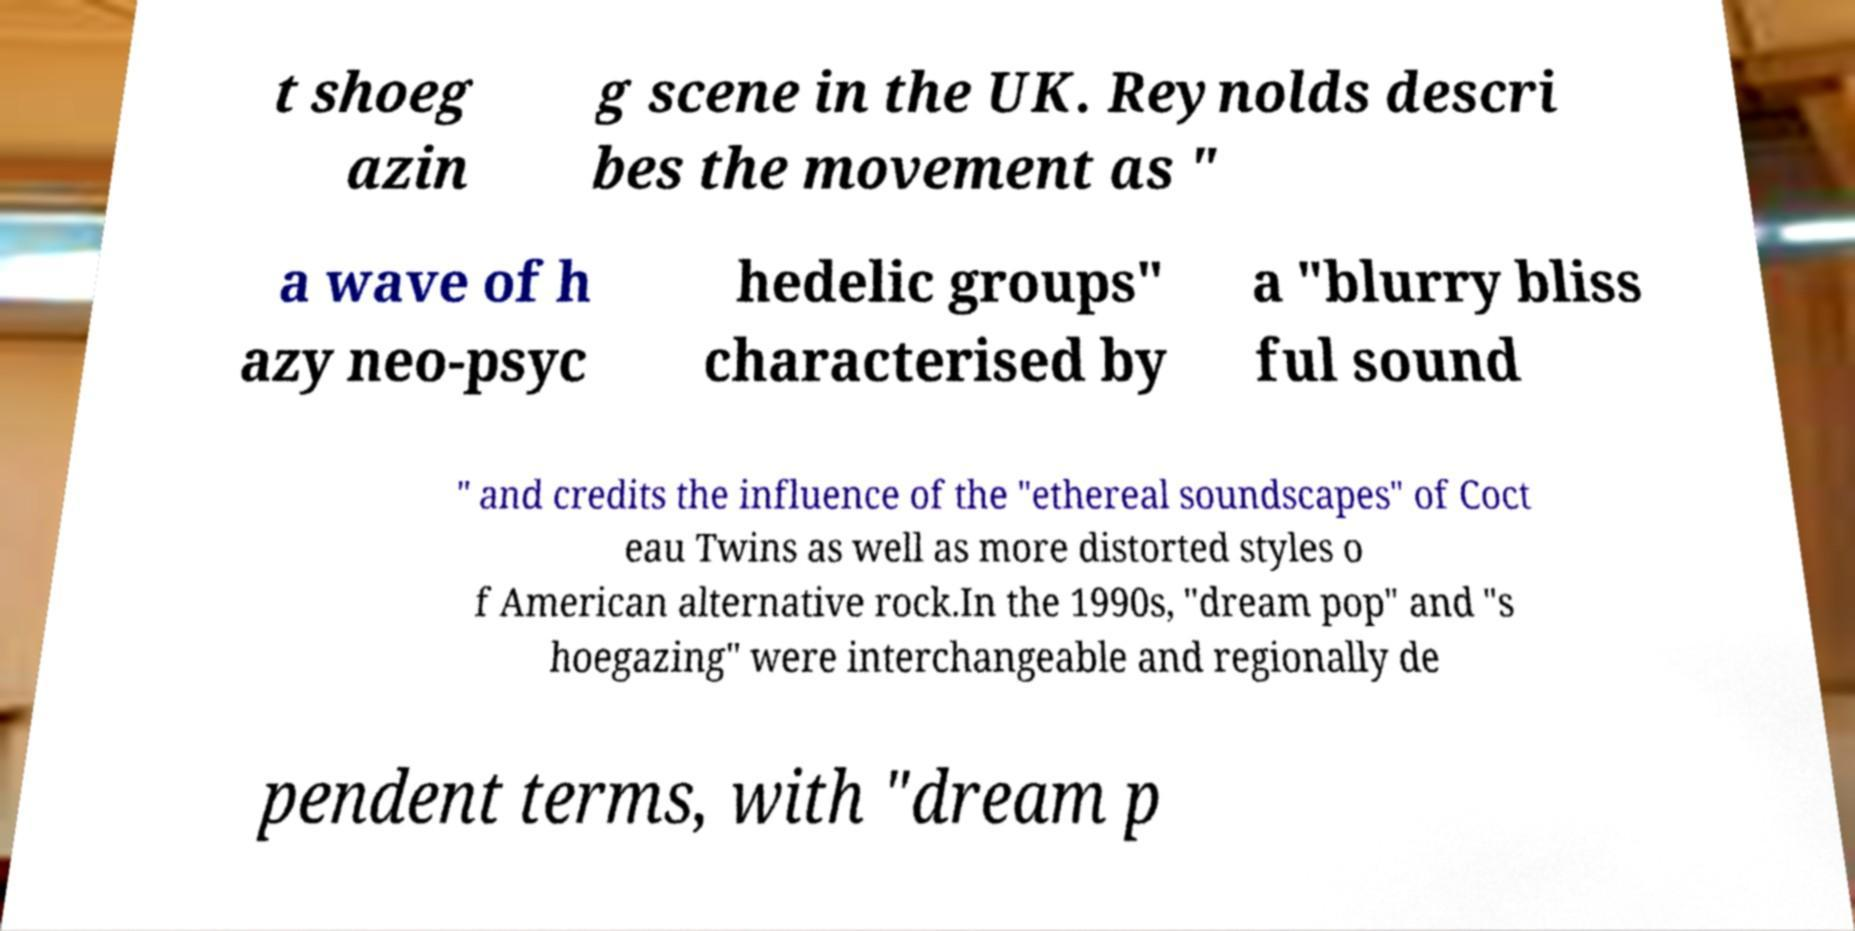I need the written content from this picture converted into text. Can you do that? t shoeg azin g scene in the UK. Reynolds descri bes the movement as " a wave of h azy neo-psyc hedelic groups" characterised by a "blurry bliss ful sound " and credits the influence of the "ethereal soundscapes" of Coct eau Twins as well as more distorted styles o f American alternative rock.In the 1990s, "dream pop" and "s hoegazing" were interchangeable and regionally de pendent terms, with "dream p 